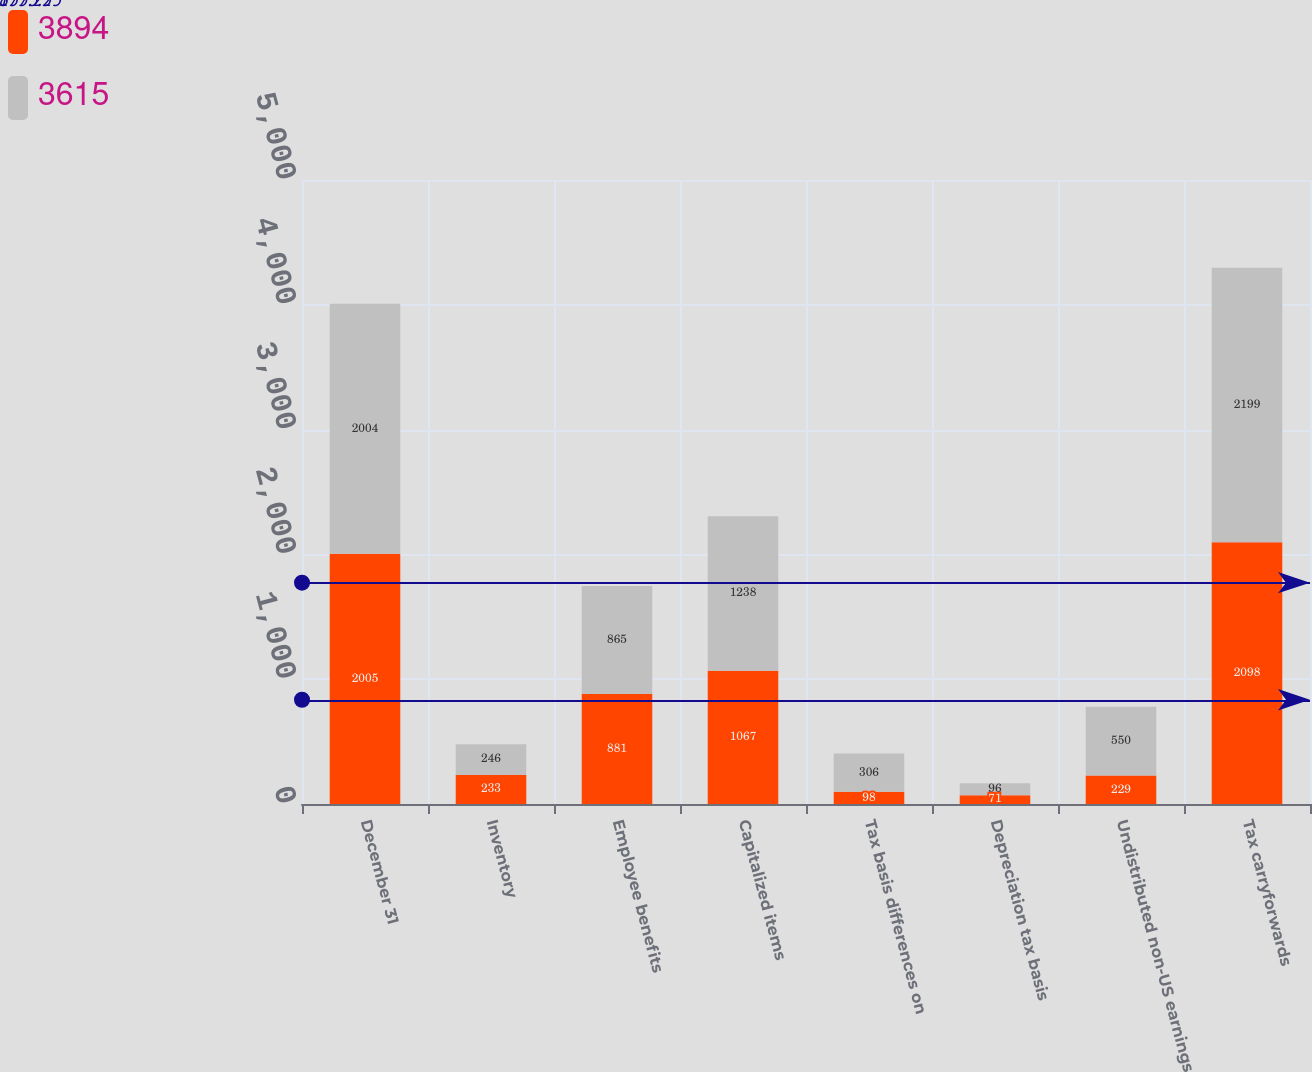Convert chart. <chart><loc_0><loc_0><loc_500><loc_500><stacked_bar_chart><ecel><fcel>December 31<fcel>Inventory<fcel>Employee benefits<fcel>Capitalized items<fcel>Tax basis differences on<fcel>Depreciation tax basis<fcel>Undistributed non-US earnings<fcel>Tax carryforwards<nl><fcel>3894<fcel>2005<fcel>233<fcel>881<fcel>1067<fcel>98<fcel>71<fcel>229<fcel>2098<nl><fcel>3615<fcel>2004<fcel>246<fcel>865<fcel>1238<fcel>306<fcel>96<fcel>550<fcel>2199<nl></chart> 